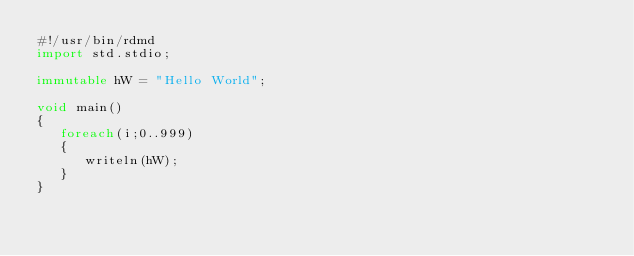Convert code to text. <code><loc_0><loc_0><loc_500><loc_500><_D_>#!/usr/bin/rdmd
import std.stdio;

immutable hW = "Hello World";

void main()
{
   foreach(i;0..999)
   {
      writeln(hW);
   }
}</code> 